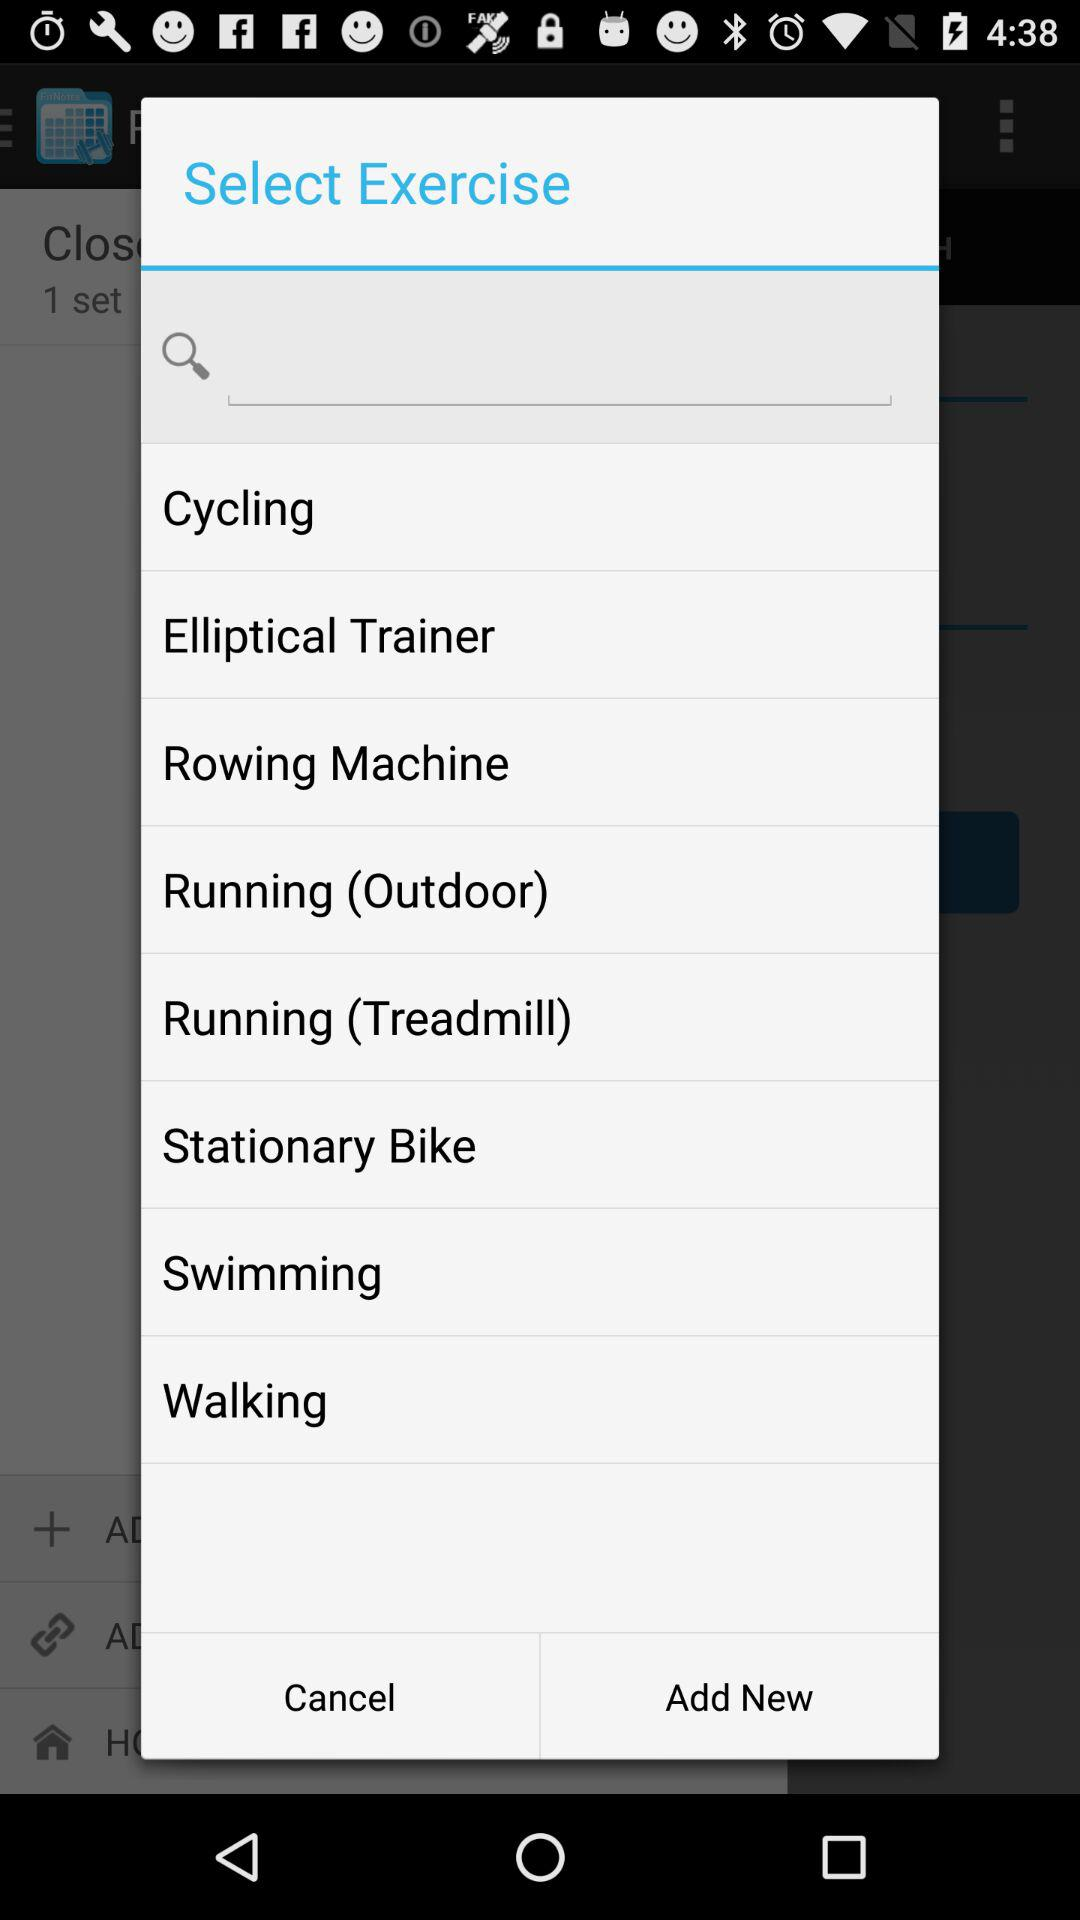What are the different available exercises? The different available exercises are cycling, running, swimming and walking. 